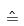<formula> <loc_0><loc_0><loc_500><loc_500>\hat { = }</formula> 